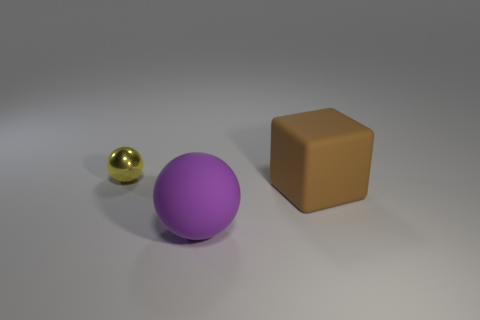The brown object is what shape?
Give a very brief answer. Cube. Is there a large purple ball that has the same material as the large brown thing?
Offer a very short reply. Yes. Is the number of brown things greater than the number of big brown spheres?
Offer a very short reply. Yes. Is the block made of the same material as the purple object?
Offer a very short reply. Yes. How many matte objects are either balls or big brown blocks?
Your answer should be very brief. 2. What is the color of the matte sphere that is the same size as the brown rubber cube?
Ensure brevity in your answer.  Purple. What number of big matte objects have the same shape as the yellow metallic thing?
Your response must be concise. 1. What number of cylinders are yellow things or big purple matte objects?
Ensure brevity in your answer.  0. There is a rubber thing that is left of the cube; does it have the same shape as the object that is behind the brown thing?
Your response must be concise. Yes. What is the small ball made of?
Provide a succinct answer. Metal. 